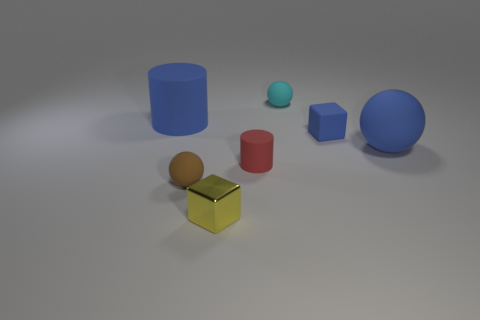There is a big sphere that is made of the same material as the tiny blue cube; what color is it?
Your response must be concise. Blue. How many metal objects are blue cylinders or tiny yellow things?
Keep it short and to the point. 1. What shape is the cyan rubber thing that is the same size as the yellow shiny block?
Keep it short and to the point. Sphere. What number of objects are either blue objects on the left side of the cyan rubber sphere or blue rubber things that are on the left side of the cyan object?
Your answer should be compact. 1. There is a blue cube that is the same size as the yellow object; what is it made of?
Your answer should be very brief. Rubber. What number of other objects are the same material as the tiny red cylinder?
Offer a terse response. 5. Is the number of brown spheres that are behind the big cylinder the same as the number of tiny red matte cylinders behind the big blue rubber sphere?
Provide a short and direct response. Yes. How many brown objects are spheres or metallic blocks?
Keep it short and to the point. 1. Do the big ball and the block in front of the small red thing have the same color?
Offer a very short reply. No. How many other objects are the same color as the big rubber sphere?
Give a very brief answer. 2. 